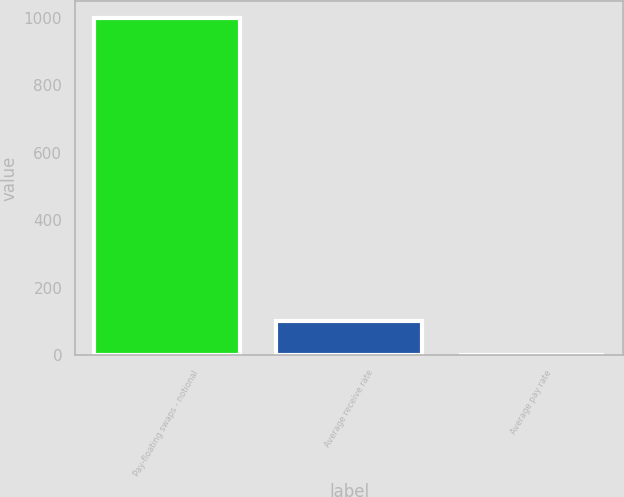Convert chart. <chart><loc_0><loc_0><loc_500><loc_500><bar_chart><fcel>Pay-floating swaps - notional<fcel>Average receive rate<fcel>Average pay rate<nl><fcel>1000<fcel>101.44<fcel>1.6<nl></chart> 